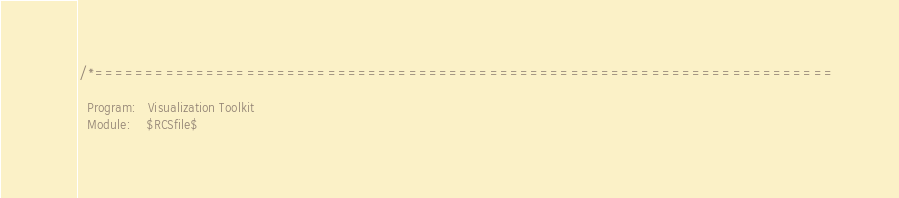<code> <loc_0><loc_0><loc_500><loc_500><_C++_>/*=========================================================================

  Program:   Visualization Toolkit
  Module:    $RCSfile$
</code> 